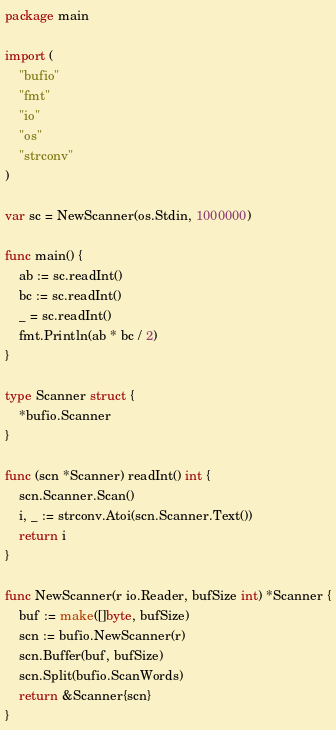Convert code to text. <code><loc_0><loc_0><loc_500><loc_500><_Go_>package main

import (
	"bufio"
	"fmt"
	"io"
	"os"
	"strconv"
)

var sc = NewScanner(os.Stdin, 1000000)

func main() {
	ab := sc.readInt()
	bc := sc.readInt()
	_ = sc.readInt()
	fmt.Println(ab * bc / 2)
}

type Scanner struct {
	*bufio.Scanner
}

func (scn *Scanner) readInt() int {
	scn.Scanner.Scan()
	i, _ := strconv.Atoi(scn.Scanner.Text())
	return i
}

func NewScanner(r io.Reader, bufSize int) *Scanner {
	buf := make([]byte, bufSize)
	scn := bufio.NewScanner(r)
	scn.Buffer(buf, bufSize)
	scn.Split(bufio.ScanWords)
	return &Scanner{scn}
}
</code> 